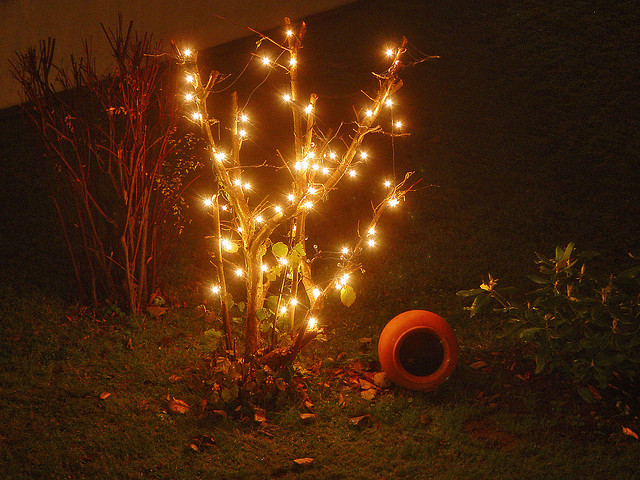<image>What energy supplies the lights? I am not sure what energy supplies the lights. It could be solar power, electrical power, or battery power. What energy supplies the lights? The lights are powered by electricity. 